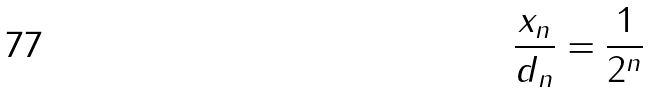<formula> <loc_0><loc_0><loc_500><loc_500>\frac { x _ { n } } { d _ { n } } = \frac { 1 } { 2 ^ { n } }</formula> 